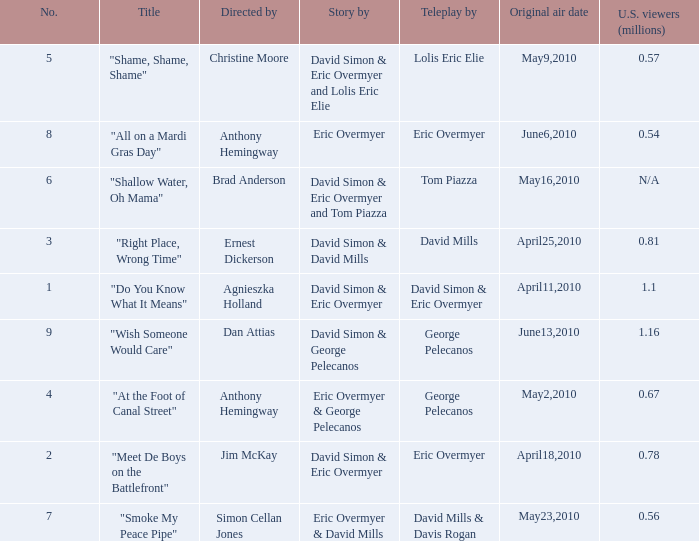Name the teleplay for  david simon & eric overmyer and tom piazza Tom Piazza. 